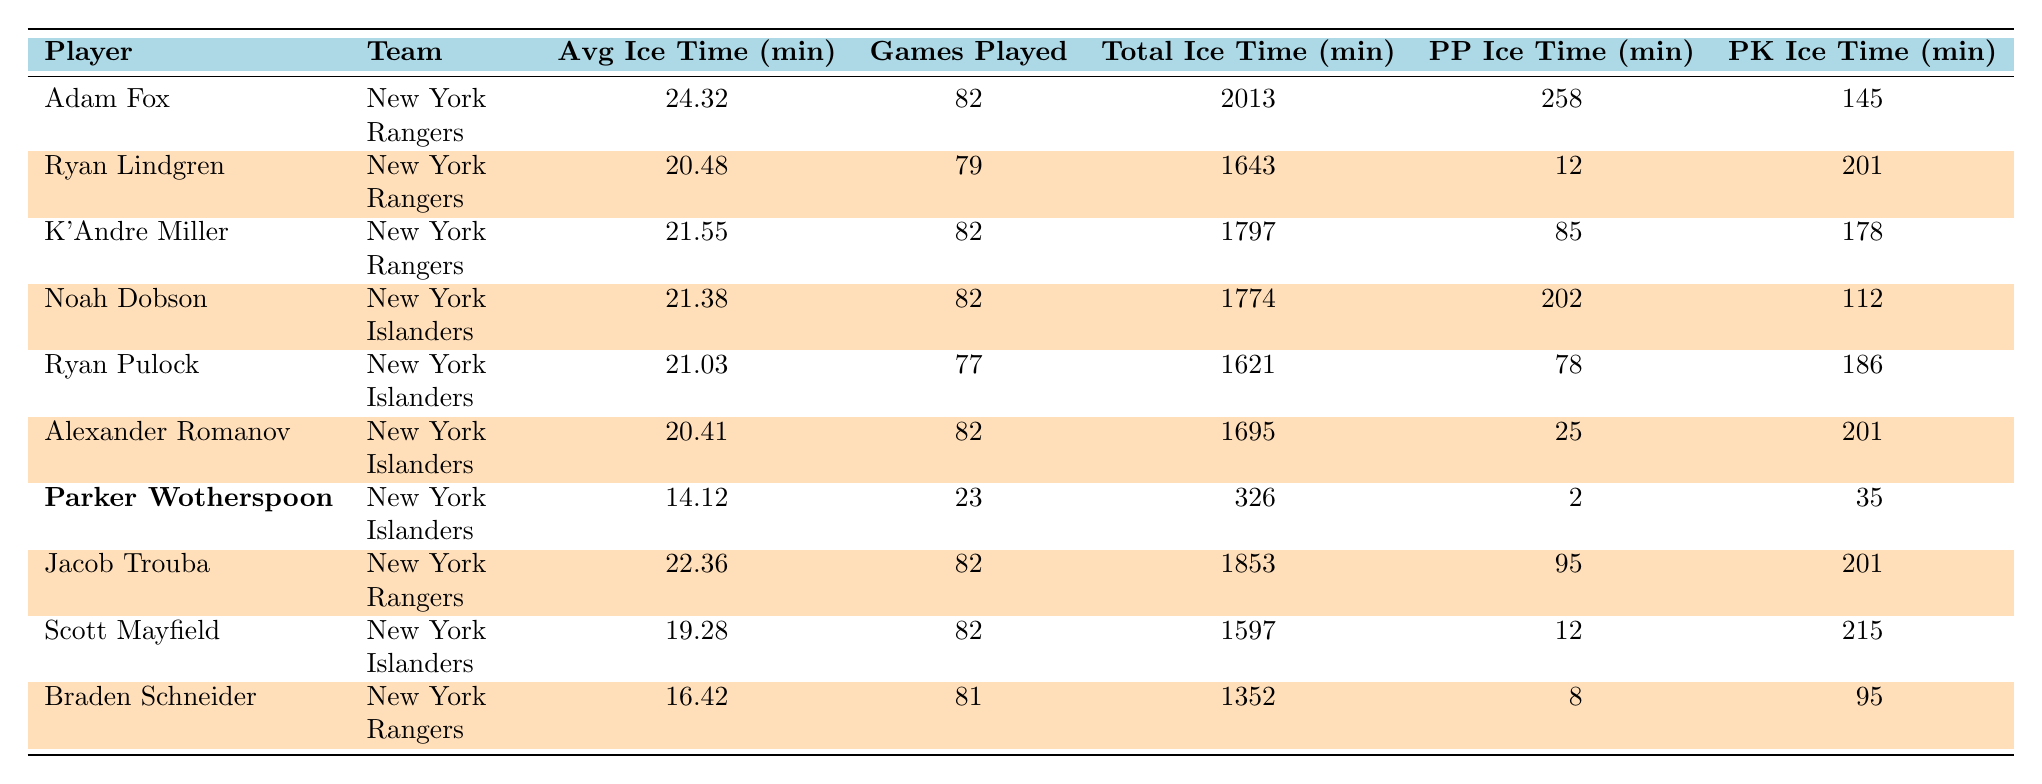What is the average ice time for Adam Fox? The table shows Adam Fox's average ice time as 24:32 minutes per game.
Answer: 24:32 Which player has the highest average ice time among New York teams? Looking at the average ice times in the table, Adam Fox has the highest at 24:32 minutes.
Answer: Adam Fox How many games did Parker Wotherspoon play? The table indicates that Parker Wotherspoon played 23 games.
Answer: 23 What is the total ice time for Ryan Pulock? Ryan Pulock's total ice time is given as 1621 minutes in the table.
Answer: 1621 How much more average ice time does Jacob Trouba have compared to Parker Wotherspoon? Jacob Trouba's average ice time is 22:36 minutes and Parker Wotherspoon's is 14:12 minutes. The difference is 22:36 - 14:12, which is 8:24.
Answer: 8:24 Did Noah Dobson play more games than Ryan Lindgren? Noah Dobson played 82 games and Ryan Lindgren played 79 games, so yes, Dobson played more games.
Answer: Yes What percentage of Parker Wotherspoon's total ice time was on the power play? Parker Wotherspoon's total ice time is 326 minutes, with 2 minutes on the power play. The percentage is (2 / 326) * 100, which is approximately 0.61%.
Answer: 0.61% Which New York Islander defenseman had the least average ice time? According to the table, Parker Wotherspoon has the least average ice time at 14:12 minutes.
Answer: Parker Wotherspoon What is the total ice time for all New York Rangers defensemen listed in the table? The total ice time for Adam Fox (2013), Ryan Lindgren (1643), K'Andre Miller (1797), Jacob Trouba (1853), and Braden Schneider (1352) is 2013 + 1643 + 1797 + 1853 + 1352 = 8598 minutes.
Answer: 8598 Do any of the New York defensemen average ice time below 20 minutes? Checking the average ice times, Parker Wotherspoon averages 14:12 minutes, which is below 20 minutes.
Answer: Yes 